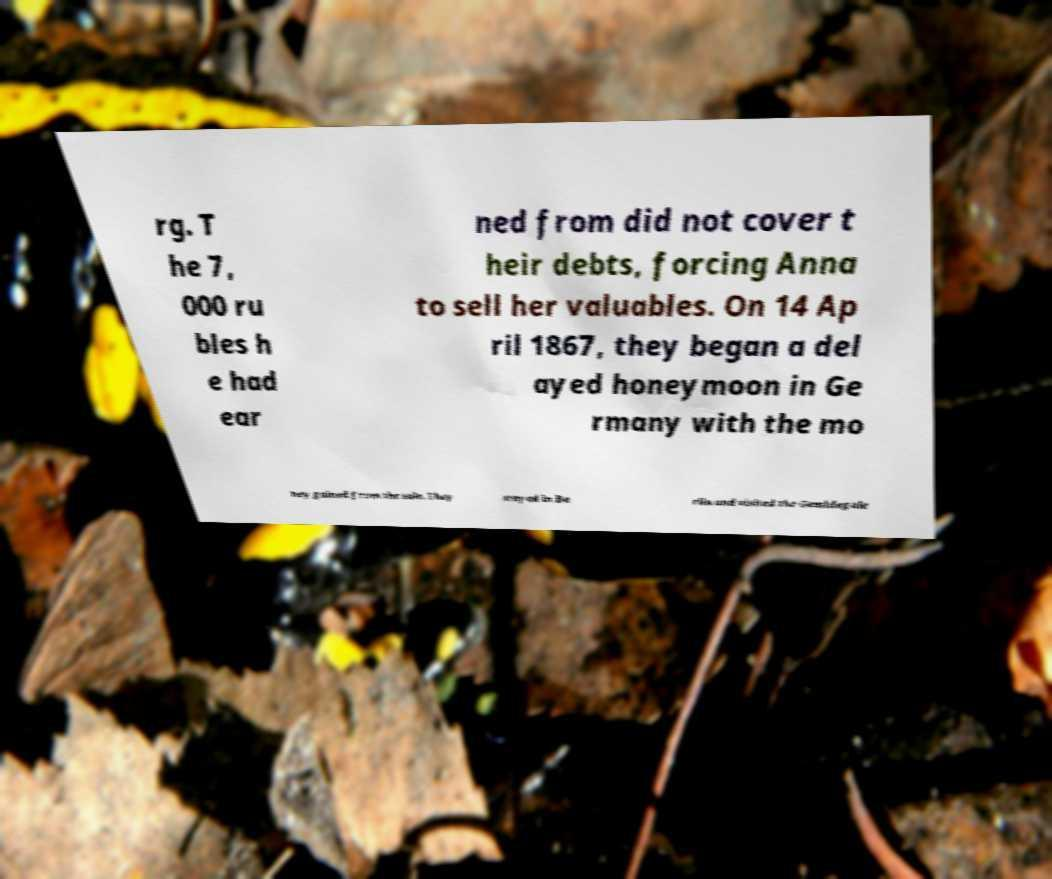Could you assist in decoding the text presented in this image and type it out clearly? rg. T he 7, 000 ru bles h e had ear ned from did not cover t heir debts, forcing Anna to sell her valuables. On 14 Ap ril 1867, they began a del ayed honeymoon in Ge rmany with the mo ney gained from the sale. They stayed in Be rlin and visited the Gemldegale 